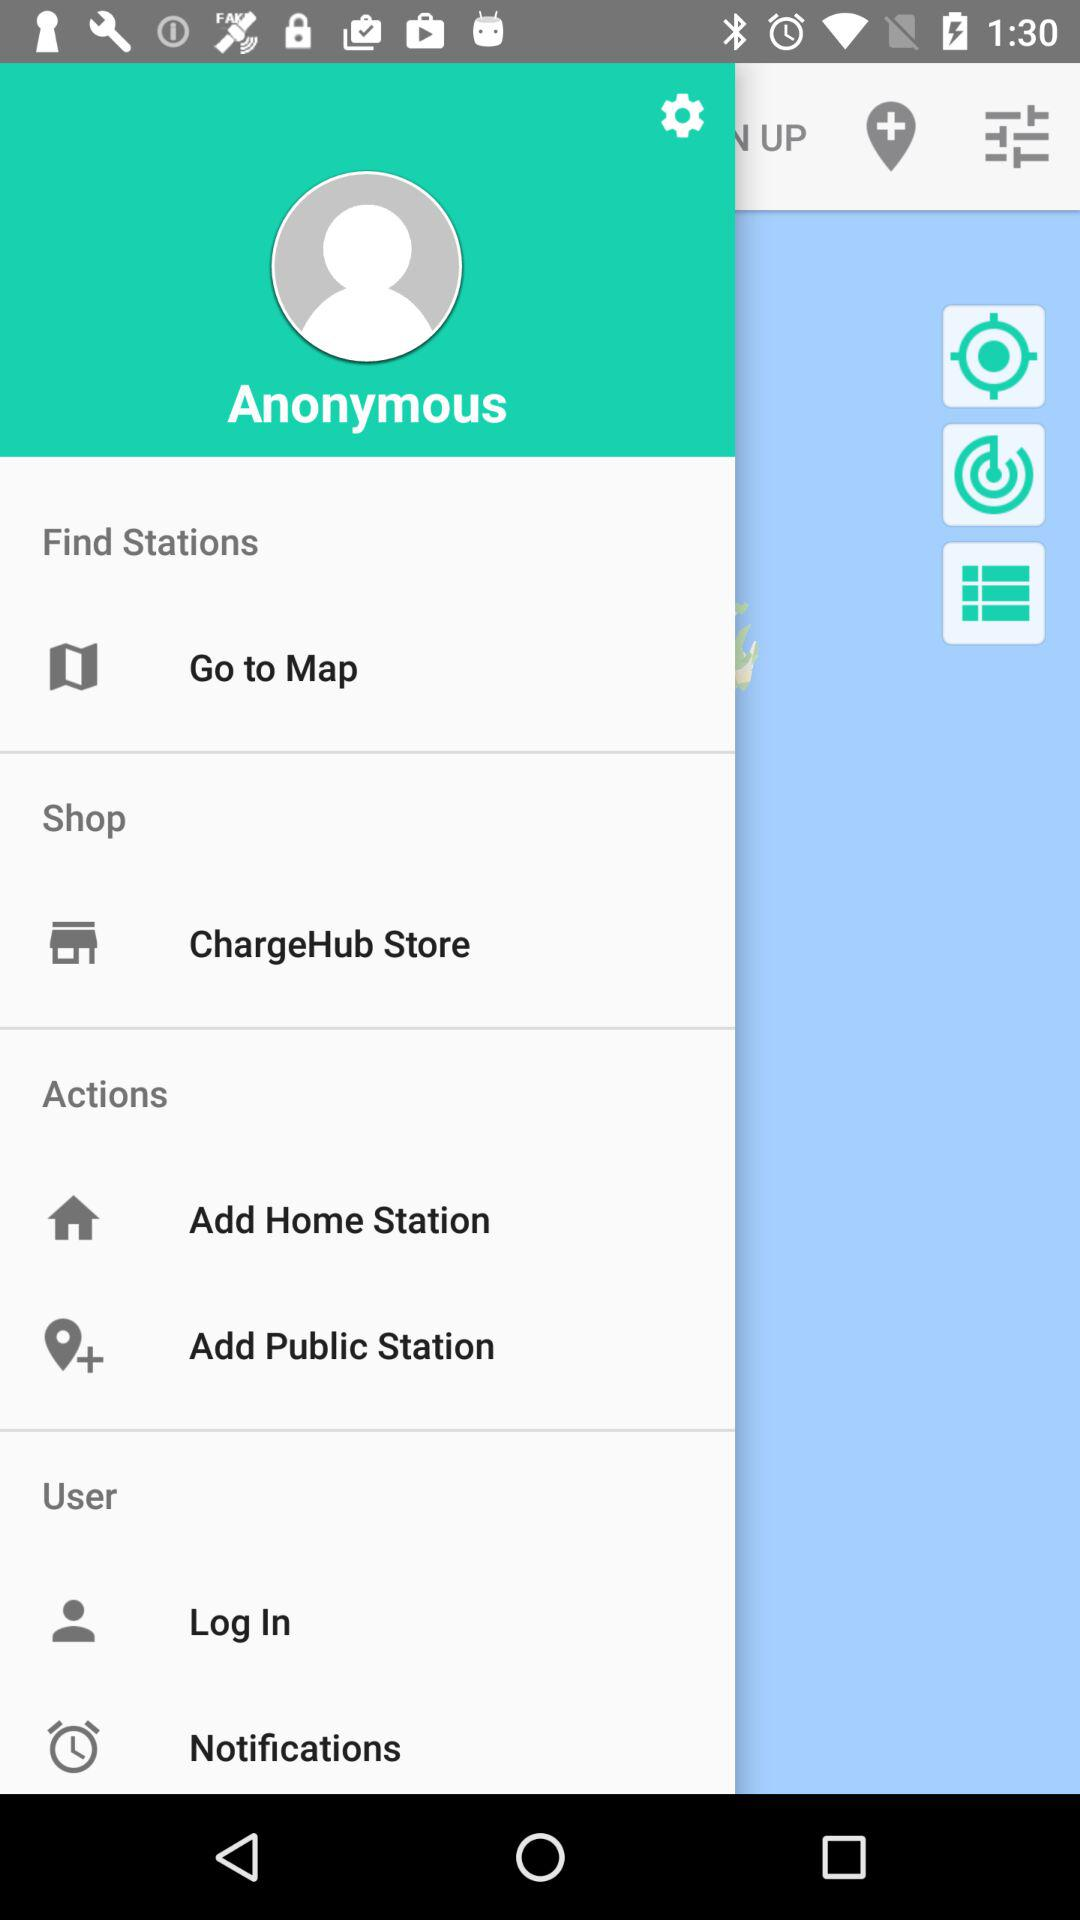What is the user's name? The user's name is Anonymous. 